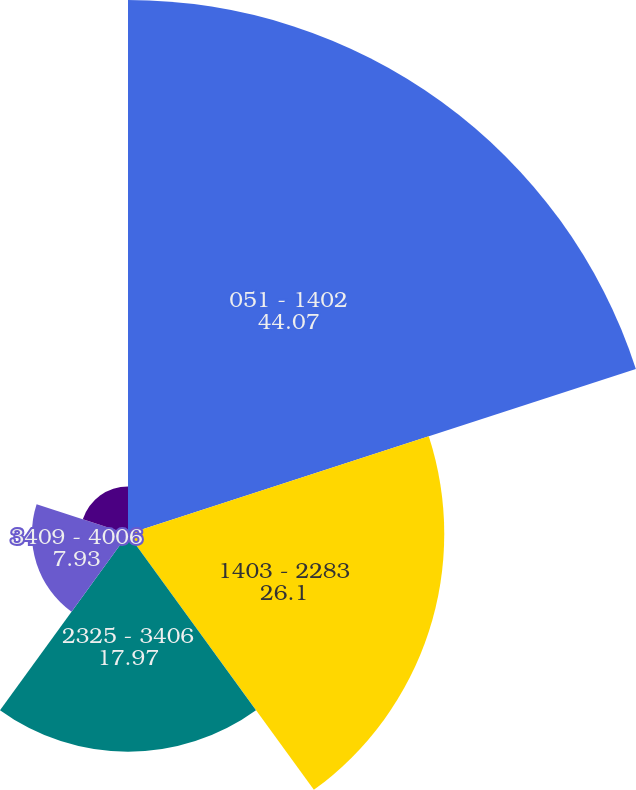Convert chart to OTSL. <chart><loc_0><loc_0><loc_500><loc_500><pie_chart><fcel>051 - 1402<fcel>1403 - 2283<fcel>2325 - 3406<fcel>3409 - 4006<fcel>4057 - 9656<nl><fcel>44.07%<fcel>26.1%<fcel>17.97%<fcel>7.93%<fcel>3.92%<nl></chart> 